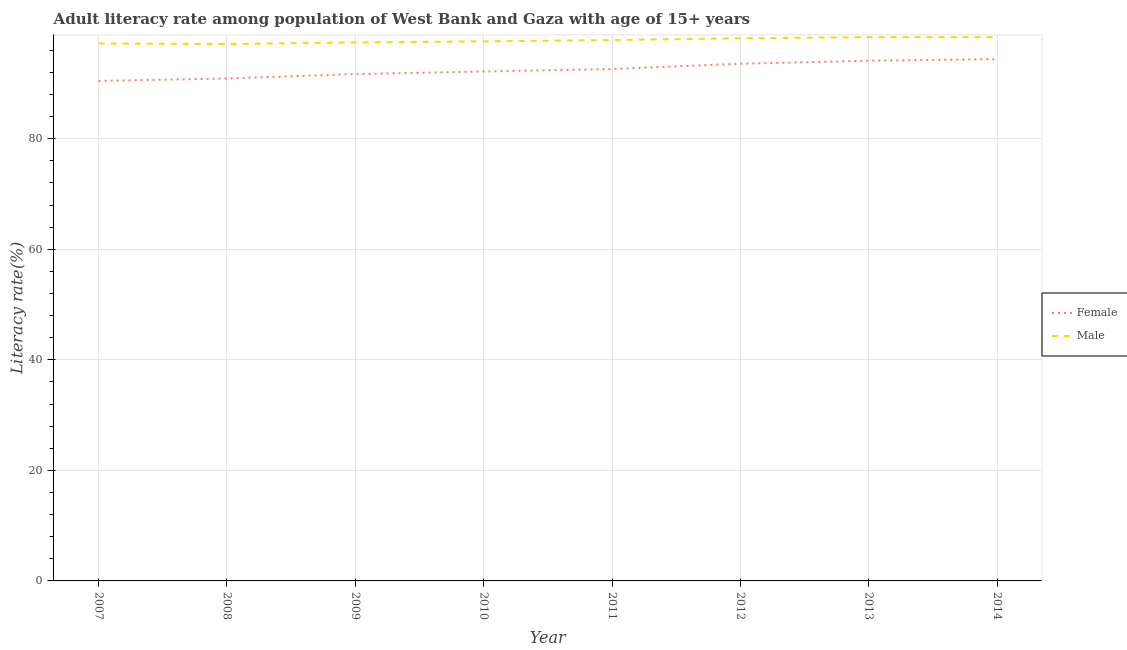How many different coloured lines are there?
Provide a short and direct response. 2. Does the line corresponding to female adult literacy rate intersect with the line corresponding to male adult literacy rate?
Ensure brevity in your answer.  No. Is the number of lines equal to the number of legend labels?
Ensure brevity in your answer.  Yes. What is the male adult literacy rate in 2014?
Offer a terse response. 98.4. Across all years, what is the maximum female adult literacy rate?
Offer a terse response. 94.41. Across all years, what is the minimum male adult literacy rate?
Your answer should be compact. 97.14. In which year was the male adult literacy rate maximum?
Offer a very short reply. 2014. What is the total female adult literacy rate in the graph?
Offer a very short reply. 739.98. What is the difference between the female adult literacy rate in 2011 and that in 2014?
Make the answer very short. -1.79. What is the difference between the female adult literacy rate in 2013 and the male adult literacy rate in 2008?
Offer a very short reply. -3.02. What is the average female adult literacy rate per year?
Offer a terse response. 92.5. In the year 2008, what is the difference between the male adult literacy rate and female adult literacy rate?
Offer a terse response. 6.24. What is the ratio of the male adult literacy rate in 2012 to that in 2014?
Your response must be concise. 1. Is the female adult literacy rate in 2008 less than that in 2009?
Provide a short and direct response. Yes. What is the difference between the highest and the second highest male adult literacy rate?
Make the answer very short. 0.01. What is the difference between the highest and the lowest female adult literacy rate?
Provide a succinct answer. 3.94. In how many years, is the female adult literacy rate greater than the average female adult literacy rate taken over all years?
Make the answer very short. 4. Is the male adult literacy rate strictly greater than the female adult literacy rate over the years?
Provide a succinct answer. Yes. How many lines are there?
Offer a terse response. 2. How many years are there in the graph?
Your answer should be compact. 8. Does the graph contain any zero values?
Your answer should be very brief. No. Does the graph contain grids?
Your answer should be very brief. Yes. Where does the legend appear in the graph?
Make the answer very short. Center right. How many legend labels are there?
Give a very brief answer. 2. How are the legend labels stacked?
Offer a terse response. Vertical. What is the title of the graph?
Provide a succinct answer. Adult literacy rate among population of West Bank and Gaza with age of 15+ years. What is the label or title of the X-axis?
Provide a succinct answer. Year. What is the label or title of the Y-axis?
Your response must be concise. Literacy rate(%). What is the Literacy rate(%) of Female in 2007?
Give a very brief answer. 90.47. What is the Literacy rate(%) of Male in 2007?
Provide a succinct answer. 97.24. What is the Literacy rate(%) in Female in 2008?
Make the answer very short. 90.9. What is the Literacy rate(%) of Male in 2008?
Ensure brevity in your answer.  97.14. What is the Literacy rate(%) of Female in 2009?
Provide a succinct answer. 91.7. What is the Literacy rate(%) of Male in 2009?
Give a very brief answer. 97.43. What is the Literacy rate(%) in Female in 2010?
Keep it short and to the point. 92.17. What is the Literacy rate(%) in Male in 2010?
Provide a short and direct response. 97.63. What is the Literacy rate(%) in Female in 2011?
Give a very brief answer. 92.62. What is the Literacy rate(%) in Male in 2011?
Your answer should be compact. 97.86. What is the Literacy rate(%) of Female in 2012?
Your answer should be compact. 93.58. What is the Literacy rate(%) in Male in 2012?
Your answer should be very brief. 98.19. What is the Literacy rate(%) of Female in 2013?
Ensure brevity in your answer.  94.13. What is the Literacy rate(%) of Male in 2013?
Ensure brevity in your answer.  98.39. What is the Literacy rate(%) in Female in 2014?
Give a very brief answer. 94.41. What is the Literacy rate(%) in Male in 2014?
Provide a short and direct response. 98.4. Across all years, what is the maximum Literacy rate(%) in Female?
Your answer should be very brief. 94.41. Across all years, what is the maximum Literacy rate(%) in Male?
Your answer should be compact. 98.4. Across all years, what is the minimum Literacy rate(%) in Female?
Offer a very short reply. 90.47. Across all years, what is the minimum Literacy rate(%) of Male?
Provide a succinct answer. 97.14. What is the total Literacy rate(%) in Female in the graph?
Your response must be concise. 739.98. What is the total Literacy rate(%) of Male in the graph?
Make the answer very short. 782.28. What is the difference between the Literacy rate(%) of Female in 2007 and that in 2008?
Your answer should be very brief. -0.44. What is the difference between the Literacy rate(%) of Male in 2007 and that in 2008?
Ensure brevity in your answer.  0.09. What is the difference between the Literacy rate(%) in Female in 2007 and that in 2009?
Your response must be concise. -1.24. What is the difference between the Literacy rate(%) in Male in 2007 and that in 2009?
Make the answer very short. -0.19. What is the difference between the Literacy rate(%) of Female in 2007 and that in 2010?
Your answer should be compact. -1.71. What is the difference between the Literacy rate(%) in Male in 2007 and that in 2010?
Offer a terse response. -0.39. What is the difference between the Literacy rate(%) in Female in 2007 and that in 2011?
Ensure brevity in your answer.  -2.15. What is the difference between the Literacy rate(%) in Male in 2007 and that in 2011?
Provide a succinct answer. -0.62. What is the difference between the Literacy rate(%) of Female in 2007 and that in 2012?
Offer a terse response. -3.12. What is the difference between the Literacy rate(%) in Male in 2007 and that in 2012?
Your answer should be compact. -0.95. What is the difference between the Literacy rate(%) in Female in 2007 and that in 2013?
Give a very brief answer. -3.66. What is the difference between the Literacy rate(%) of Male in 2007 and that in 2013?
Your answer should be very brief. -1.15. What is the difference between the Literacy rate(%) in Female in 2007 and that in 2014?
Make the answer very short. -3.94. What is the difference between the Literacy rate(%) in Male in 2007 and that in 2014?
Ensure brevity in your answer.  -1.17. What is the difference between the Literacy rate(%) in Female in 2008 and that in 2009?
Your response must be concise. -0.8. What is the difference between the Literacy rate(%) in Male in 2008 and that in 2009?
Your answer should be very brief. -0.29. What is the difference between the Literacy rate(%) in Female in 2008 and that in 2010?
Offer a terse response. -1.27. What is the difference between the Literacy rate(%) of Male in 2008 and that in 2010?
Make the answer very short. -0.48. What is the difference between the Literacy rate(%) of Female in 2008 and that in 2011?
Provide a succinct answer. -1.71. What is the difference between the Literacy rate(%) in Male in 2008 and that in 2011?
Give a very brief answer. -0.71. What is the difference between the Literacy rate(%) of Female in 2008 and that in 2012?
Your answer should be very brief. -2.68. What is the difference between the Literacy rate(%) in Male in 2008 and that in 2012?
Provide a succinct answer. -1.05. What is the difference between the Literacy rate(%) in Female in 2008 and that in 2013?
Provide a succinct answer. -3.22. What is the difference between the Literacy rate(%) of Male in 2008 and that in 2013?
Provide a succinct answer. -1.25. What is the difference between the Literacy rate(%) in Female in 2008 and that in 2014?
Offer a terse response. -3.5. What is the difference between the Literacy rate(%) of Male in 2008 and that in 2014?
Offer a very short reply. -1.26. What is the difference between the Literacy rate(%) in Female in 2009 and that in 2010?
Provide a short and direct response. -0.47. What is the difference between the Literacy rate(%) of Male in 2009 and that in 2010?
Ensure brevity in your answer.  -0.2. What is the difference between the Literacy rate(%) of Female in 2009 and that in 2011?
Give a very brief answer. -0.91. What is the difference between the Literacy rate(%) in Male in 2009 and that in 2011?
Provide a succinct answer. -0.43. What is the difference between the Literacy rate(%) of Female in 2009 and that in 2012?
Provide a short and direct response. -1.88. What is the difference between the Literacy rate(%) in Male in 2009 and that in 2012?
Your answer should be very brief. -0.76. What is the difference between the Literacy rate(%) in Female in 2009 and that in 2013?
Provide a short and direct response. -2.42. What is the difference between the Literacy rate(%) of Male in 2009 and that in 2013?
Ensure brevity in your answer.  -0.96. What is the difference between the Literacy rate(%) of Female in 2009 and that in 2014?
Provide a short and direct response. -2.7. What is the difference between the Literacy rate(%) of Male in 2009 and that in 2014?
Provide a short and direct response. -0.97. What is the difference between the Literacy rate(%) in Female in 2010 and that in 2011?
Your answer should be compact. -0.44. What is the difference between the Literacy rate(%) of Male in 2010 and that in 2011?
Provide a succinct answer. -0.23. What is the difference between the Literacy rate(%) in Female in 2010 and that in 2012?
Provide a succinct answer. -1.41. What is the difference between the Literacy rate(%) of Male in 2010 and that in 2012?
Provide a short and direct response. -0.56. What is the difference between the Literacy rate(%) in Female in 2010 and that in 2013?
Make the answer very short. -1.95. What is the difference between the Literacy rate(%) in Male in 2010 and that in 2013?
Your answer should be compact. -0.76. What is the difference between the Literacy rate(%) in Female in 2010 and that in 2014?
Keep it short and to the point. -2.23. What is the difference between the Literacy rate(%) of Male in 2010 and that in 2014?
Ensure brevity in your answer.  -0.77. What is the difference between the Literacy rate(%) in Female in 2011 and that in 2012?
Make the answer very short. -0.96. What is the difference between the Literacy rate(%) in Male in 2011 and that in 2012?
Your answer should be compact. -0.33. What is the difference between the Literacy rate(%) of Female in 2011 and that in 2013?
Your answer should be compact. -1.51. What is the difference between the Literacy rate(%) in Male in 2011 and that in 2013?
Your answer should be compact. -0.53. What is the difference between the Literacy rate(%) in Female in 2011 and that in 2014?
Give a very brief answer. -1.79. What is the difference between the Literacy rate(%) in Male in 2011 and that in 2014?
Provide a short and direct response. -0.55. What is the difference between the Literacy rate(%) in Female in 2012 and that in 2013?
Your response must be concise. -0.55. What is the difference between the Literacy rate(%) of Male in 2012 and that in 2013?
Your response must be concise. -0.2. What is the difference between the Literacy rate(%) in Female in 2012 and that in 2014?
Offer a very short reply. -0.83. What is the difference between the Literacy rate(%) in Male in 2012 and that in 2014?
Ensure brevity in your answer.  -0.21. What is the difference between the Literacy rate(%) of Female in 2013 and that in 2014?
Provide a short and direct response. -0.28. What is the difference between the Literacy rate(%) in Male in 2013 and that in 2014?
Provide a short and direct response. -0.01. What is the difference between the Literacy rate(%) of Female in 2007 and the Literacy rate(%) of Male in 2008?
Give a very brief answer. -6.68. What is the difference between the Literacy rate(%) in Female in 2007 and the Literacy rate(%) in Male in 2009?
Offer a terse response. -6.97. What is the difference between the Literacy rate(%) in Female in 2007 and the Literacy rate(%) in Male in 2010?
Your response must be concise. -7.16. What is the difference between the Literacy rate(%) of Female in 2007 and the Literacy rate(%) of Male in 2011?
Give a very brief answer. -7.39. What is the difference between the Literacy rate(%) of Female in 2007 and the Literacy rate(%) of Male in 2012?
Offer a very short reply. -7.73. What is the difference between the Literacy rate(%) in Female in 2007 and the Literacy rate(%) in Male in 2013?
Your answer should be compact. -7.93. What is the difference between the Literacy rate(%) in Female in 2007 and the Literacy rate(%) in Male in 2014?
Provide a succinct answer. -7.94. What is the difference between the Literacy rate(%) of Female in 2008 and the Literacy rate(%) of Male in 2009?
Keep it short and to the point. -6.53. What is the difference between the Literacy rate(%) in Female in 2008 and the Literacy rate(%) in Male in 2010?
Provide a short and direct response. -6.73. What is the difference between the Literacy rate(%) in Female in 2008 and the Literacy rate(%) in Male in 2011?
Keep it short and to the point. -6.95. What is the difference between the Literacy rate(%) in Female in 2008 and the Literacy rate(%) in Male in 2012?
Your answer should be very brief. -7.29. What is the difference between the Literacy rate(%) of Female in 2008 and the Literacy rate(%) of Male in 2013?
Provide a succinct answer. -7.49. What is the difference between the Literacy rate(%) in Female in 2008 and the Literacy rate(%) in Male in 2014?
Offer a terse response. -7.5. What is the difference between the Literacy rate(%) of Female in 2009 and the Literacy rate(%) of Male in 2010?
Offer a terse response. -5.92. What is the difference between the Literacy rate(%) of Female in 2009 and the Literacy rate(%) of Male in 2011?
Your response must be concise. -6.15. What is the difference between the Literacy rate(%) in Female in 2009 and the Literacy rate(%) in Male in 2012?
Offer a terse response. -6.49. What is the difference between the Literacy rate(%) of Female in 2009 and the Literacy rate(%) of Male in 2013?
Ensure brevity in your answer.  -6.69. What is the difference between the Literacy rate(%) in Female in 2009 and the Literacy rate(%) in Male in 2014?
Keep it short and to the point. -6.7. What is the difference between the Literacy rate(%) of Female in 2010 and the Literacy rate(%) of Male in 2011?
Keep it short and to the point. -5.68. What is the difference between the Literacy rate(%) in Female in 2010 and the Literacy rate(%) in Male in 2012?
Your response must be concise. -6.02. What is the difference between the Literacy rate(%) in Female in 2010 and the Literacy rate(%) in Male in 2013?
Your response must be concise. -6.22. What is the difference between the Literacy rate(%) of Female in 2010 and the Literacy rate(%) of Male in 2014?
Your answer should be compact. -6.23. What is the difference between the Literacy rate(%) of Female in 2011 and the Literacy rate(%) of Male in 2012?
Ensure brevity in your answer.  -5.58. What is the difference between the Literacy rate(%) in Female in 2011 and the Literacy rate(%) in Male in 2013?
Make the answer very short. -5.78. What is the difference between the Literacy rate(%) of Female in 2011 and the Literacy rate(%) of Male in 2014?
Your answer should be compact. -5.79. What is the difference between the Literacy rate(%) in Female in 2012 and the Literacy rate(%) in Male in 2013?
Your answer should be compact. -4.81. What is the difference between the Literacy rate(%) of Female in 2012 and the Literacy rate(%) of Male in 2014?
Give a very brief answer. -4.82. What is the difference between the Literacy rate(%) of Female in 2013 and the Literacy rate(%) of Male in 2014?
Ensure brevity in your answer.  -4.28. What is the average Literacy rate(%) of Female per year?
Offer a terse response. 92.5. What is the average Literacy rate(%) in Male per year?
Provide a short and direct response. 97.79. In the year 2007, what is the difference between the Literacy rate(%) in Female and Literacy rate(%) in Male?
Offer a terse response. -6.77. In the year 2008, what is the difference between the Literacy rate(%) of Female and Literacy rate(%) of Male?
Make the answer very short. -6.24. In the year 2009, what is the difference between the Literacy rate(%) of Female and Literacy rate(%) of Male?
Offer a very short reply. -5.73. In the year 2010, what is the difference between the Literacy rate(%) of Female and Literacy rate(%) of Male?
Provide a short and direct response. -5.46. In the year 2011, what is the difference between the Literacy rate(%) in Female and Literacy rate(%) in Male?
Your answer should be very brief. -5.24. In the year 2012, what is the difference between the Literacy rate(%) of Female and Literacy rate(%) of Male?
Provide a succinct answer. -4.61. In the year 2013, what is the difference between the Literacy rate(%) in Female and Literacy rate(%) in Male?
Your answer should be very brief. -4.27. In the year 2014, what is the difference between the Literacy rate(%) of Female and Literacy rate(%) of Male?
Offer a very short reply. -4. What is the ratio of the Literacy rate(%) of Female in 2007 to that in 2008?
Offer a very short reply. 1. What is the ratio of the Literacy rate(%) of Female in 2007 to that in 2009?
Keep it short and to the point. 0.99. What is the ratio of the Literacy rate(%) of Male in 2007 to that in 2009?
Provide a short and direct response. 1. What is the ratio of the Literacy rate(%) of Female in 2007 to that in 2010?
Keep it short and to the point. 0.98. What is the ratio of the Literacy rate(%) of Female in 2007 to that in 2011?
Your response must be concise. 0.98. What is the ratio of the Literacy rate(%) in Female in 2007 to that in 2012?
Give a very brief answer. 0.97. What is the ratio of the Literacy rate(%) of Male in 2007 to that in 2012?
Provide a succinct answer. 0.99. What is the ratio of the Literacy rate(%) in Female in 2007 to that in 2013?
Offer a very short reply. 0.96. What is the ratio of the Literacy rate(%) in Male in 2007 to that in 2013?
Offer a terse response. 0.99. What is the ratio of the Literacy rate(%) of Female in 2007 to that in 2014?
Provide a succinct answer. 0.96. What is the ratio of the Literacy rate(%) of Male in 2007 to that in 2014?
Provide a short and direct response. 0.99. What is the ratio of the Literacy rate(%) in Female in 2008 to that in 2009?
Make the answer very short. 0.99. What is the ratio of the Literacy rate(%) of Male in 2008 to that in 2009?
Make the answer very short. 1. What is the ratio of the Literacy rate(%) of Female in 2008 to that in 2010?
Offer a very short reply. 0.99. What is the ratio of the Literacy rate(%) of Female in 2008 to that in 2011?
Make the answer very short. 0.98. What is the ratio of the Literacy rate(%) of Female in 2008 to that in 2012?
Keep it short and to the point. 0.97. What is the ratio of the Literacy rate(%) of Male in 2008 to that in 2012?
Your answer should be compact. 0.99. What is the ratio of the Literacy rate(%) of Female in 2008 to that in 2013?
Provide a succinct answer. 0.97. What is the ratio of the Literacy rate(%) of Male in 2008 to that in 2013?
Keep it short and to the point. 0.99. What is the ratio of the Literacy rate(%) in Female in 2008 to that in 2014?
Provide a short and direct response. 0.96. What is the ratio of the Literacy rate(%) in Male in 2008 to that in 2014?
Your answer should be compact. 0.99. What is the ratio of the Literacy rate(%) of Female in 2009 to that in 2010?
Provide a short and direct response. 0.99. What is the ratio of the Literacy rate(%) of Male in 2009 to that in 2010?
Make the answer very short. 1. What is the ratio of the Literacy rate(%) in Female in 2009 to that in 2011?
Offer a very short reply. 0.99. What is the ratio of the Literacy rate(%) of Male in 2009 to that in 2011?
Give a very brief answer. 1. What is the ratio of the Literacy rate(%) of Male in 2009 to that in 2012?
Your answer should be compact. 0.99. What is the ratio of the Literacy rate(%) in Female in 2009 to that in 2013?
Your response must be concise. 0.97. What is the ratio of the Literacy rate(%) in Male in 2009 to that in 2013?
Your response must be concise. 0.99. What is the ratio of the Literacy rate(%) in Female in 2009 to that in 2014?
Offer a very short reply. 0.97. What is the ratio of the Literacy rate(%) in Female in 2010 to that in 2013?
Give a very brief answer. 0.98. What is the ratio of the Literacy rate(%) in Male in 2010 to that in 2013?
Your answer should be very brief. 0.99. What is the ratio of the Literacy rate(%) in Female in 2010 to that in 2014?
Your response must be concise. 0.98. What is the ratio of the Literacy rate(%) of Male in 2010 to that in 2014?
Give a very brief answer. 0.99. What is the ratio of the Literacy rate(%) in Female in 2011 to that in 2013?
Your answer should be very brief. 0.98. What is the ratio of the Literacy rate(%) of Female in 2011 to that in 2014?
Offer a very short reply. 0.98. What is the ratio of the Literacy rate(%) in Male in 2013 to that in 2014?
Provide a succinct answer. 1. What is the difference between the highest and the second highest Literacy rate(%) of Female?
Ensure brevity in your answer.  0.28. What is the difference between the highest and the second highest Literacy rate(%) in Male?
Provide a succinct answer. 0.01. What is the difference between the highest and the lowest Literacy rate(%) in Female?
Your response must be concise. 3.94. What is the difference between the highest and the lowest Literacy rate(%) in Male?
Offer a terse response. 1.26. 